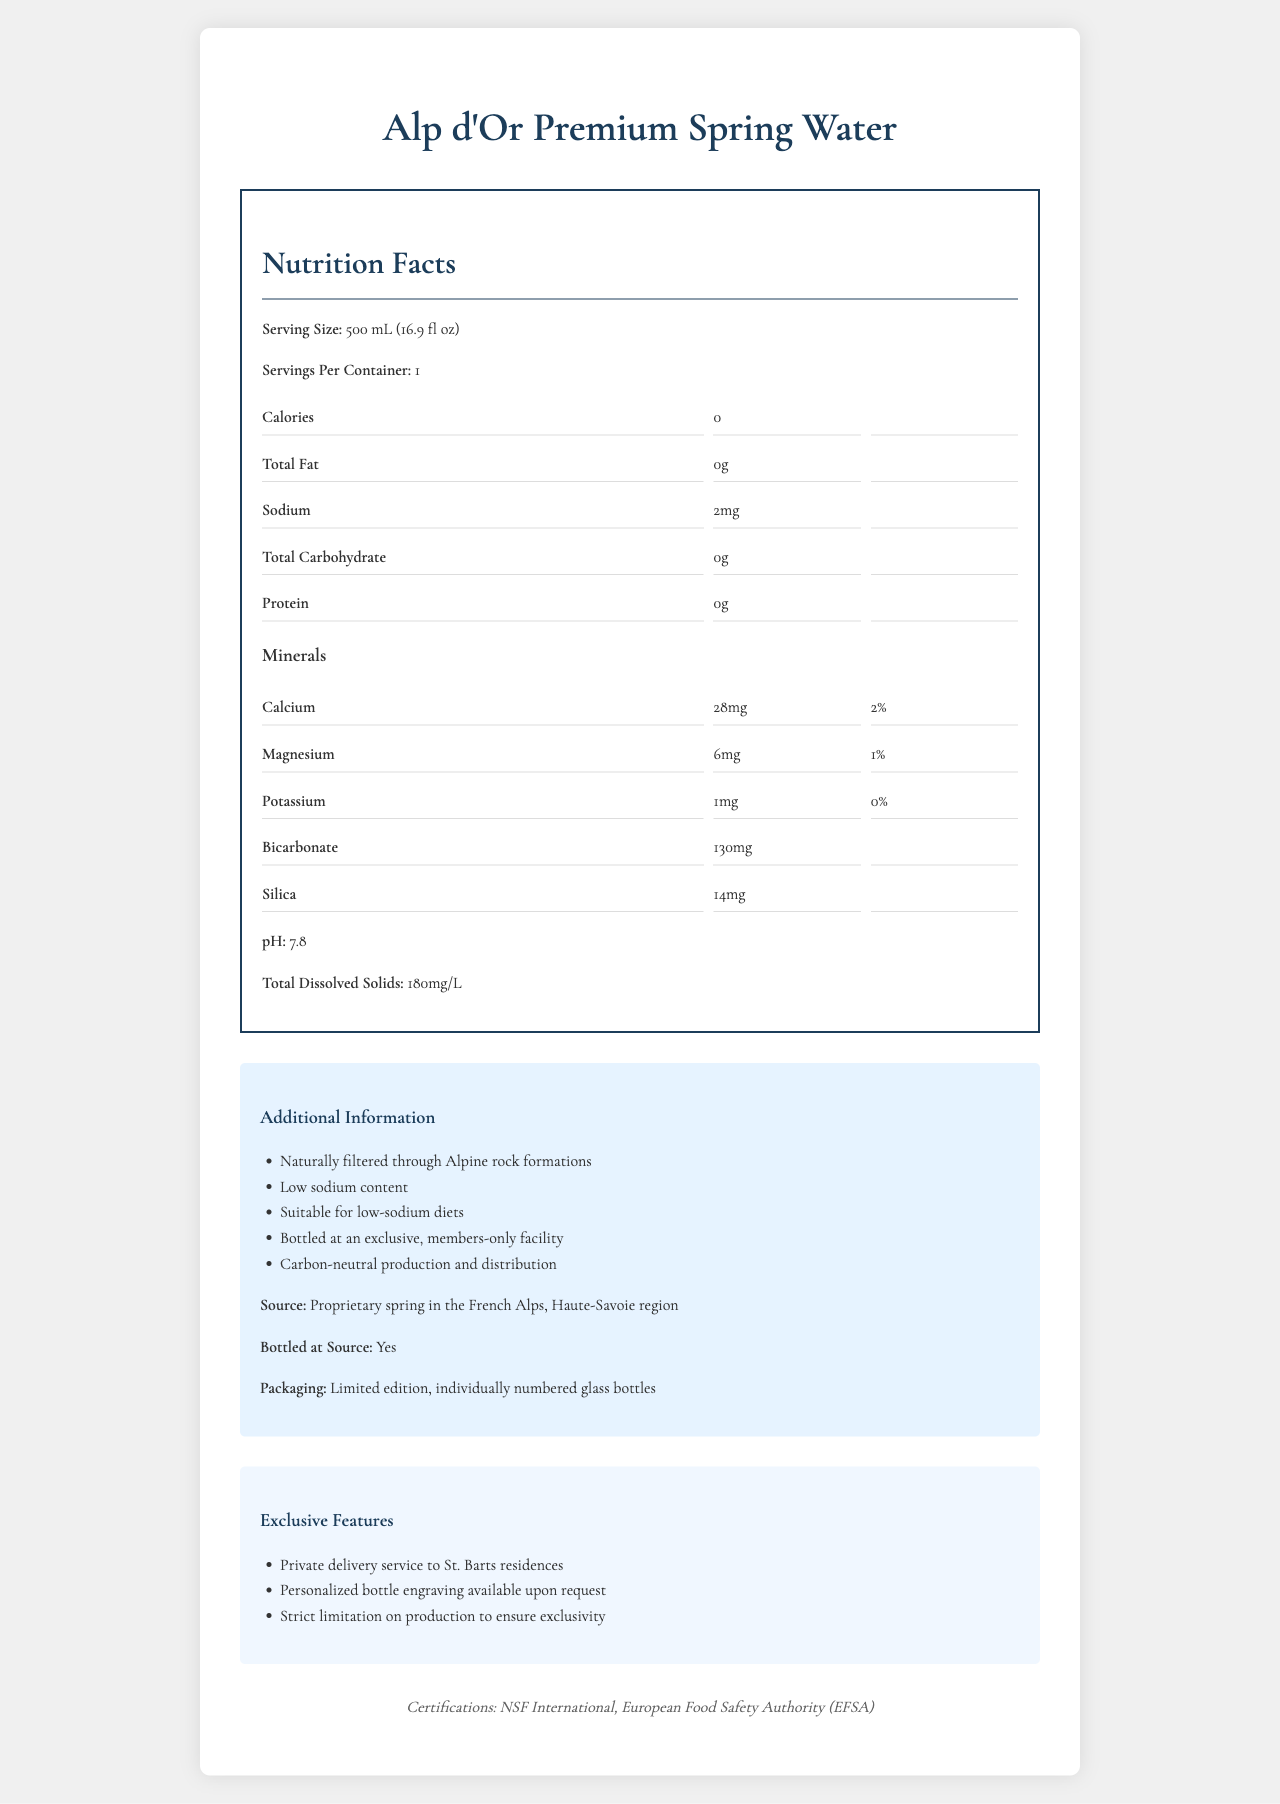how much sodium is in one serving? The document states that the sodium content per serving is 2mg.
Answer: 2mg what is the serving size for the Alp d'Or Premium Spring Water? The serving size is listed as 500 mL (16.9 fl oz) in the document.
Answer: 500 mL (16.9 fl oz) does the Alp d'Or Premium Spring Water contain any calories? The document indicates that there are 0 calories per serving.
Answer: No how much calcium is in a serving? The document mentions that there is 28mg of calcium per serving.
Answer: 28mg what is the pH level of the Alp d'Or Premium Spring Water? The pH level is specified as 7.8 in the document.
Answer: 7.8 which mineral is present in the greatest amount in the Alp d'Or Premium Spring Water? A. Calcium B. Magnesium C. Potassium D. Bicarbonate The document lists bicarbonate as having 130mg, which is the highest amount among the minerals listed.
Answer: D. Bicarbonate what percentage of the daily value of magnesium does one serving provide? A. 1% B. 2% C. 3% D. 5% The document states that one serving of the water provides 1% of the daily value of magnesium.
Answer: A. 1% does this water contain protein? The document indicates that there is 0g of protein per serving.
Answer: No is the Alp d'Or Premium Spring Water suitable for low-sodium diets? The document states that it has low sodium content and is suitable for low-sodium diets.
Answer: Yes where is the source of this premium water located? The document specifies that the source of the water is a proprietary spring in the French Alps, Haute-Savoie region.
Answer: Haute-Savoie region in the French Alps is the water bottled at the source? The document confirms that the water is bottled at the source.
Answer: Yes what special feature does the packaging of Alp d'Or Premium Spring Water have? According to the document, the packaging feature includes limited edition, individually numbered glass bottles.
Answer: Limited edition, individually numbered glass bottles please describe the main features of the Alp d'Or Premium Spring Water. The document provides detailed information about the product name, nutritional information, mineral content, source, packaging, additional information, and exclusive features of Alp d'Or Premium Spring Water.
Answer: Alp d'Or Premium Spring Water is a high-end bottled spring water sourced from a proprietary spring in the French Alps, specifically the Haute-Savoie region. It is bottled at the source in limited edition, individually numbered glass bottles. The water has a pH of 7.8, contains essential minerals like calcium, magnesium, potassium, bicarbonate, and silica, and has low sodium content, making it suitable for low-sodium diets. It is certified by NSF International and the European Food Safety Authority. Exclusive features include private delivery to St. Barts residences, personalized bottle engraving, and limited production to ensure exclusivity. does the Alp d'Or Premium Spring Water have a high calorie content? The document states that the water contains 0 calories, so it cannot be determined if any calorie content is considered high by different standards.
Answer: Not enough information is the total carbohydrate content more than 1g per serving? The document clearly indicates that the total carbohydrate content is 0g per serving.
Answer: No what certifications has the Alp d'Or Premium Spring Water received? The document lists NSF International and EFSA as the certifications received by the water.
Answer: NSF International and European Food Safety Authority (EFSA) 